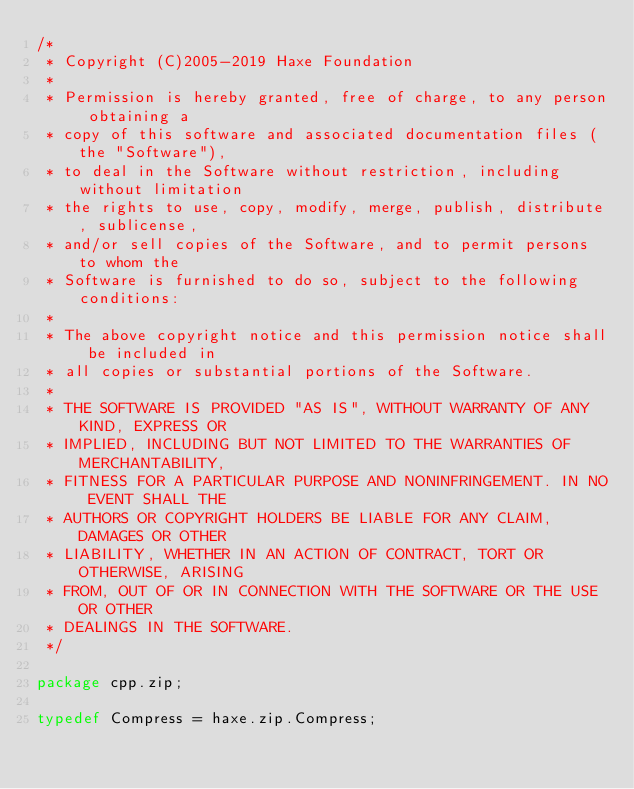<code> <loc_0><loc_0><loc_500><loc_500><_Haxe_>/*
 * Copyright (C)2005-2019 Haxe Foundation
 *
 * Permission is hereby granted, free of charge, to any person obtaining a
 * copy of this software and associated documentation files (the "Software"),
 * to deal in the Software without restriction, including without limitation
 * the rights to use, copy, modify, merge, publish, distribute, sublicense,
 * and/or sell copies of the Software, and to permit persons to whom the
 * Software is furnished to do so, subject to the following conditions:
 *
 * The above copyright notice and this permission notice shall be included in
 * all copies or substantial portions of the Software.
 *
 * THE SOFTWARE IS PROVIDED "AS IS", WITHOUT WARRANTY OF ANY KIND, EXPRESS OR
 * IMPLIED, INCLUDING BUT NOT LIMITED TO THE WARRANTIES OF MERCHANTABILITY,
 * FITNESS FOR A PARTICULAR PURPOSE AND NONINFRINGEMENT. IN NO EVENT SHALL THE
 * AUTHORS OR COPYRIGHT HOLDERS BE LIABLE FOR ANY CLAIM, DAMAGES OR OTHER
 * LIABILITY, WHETHER IN AN ACTION OF CONTRACT, TORT OR OTHERWISE, ARISING
 * FROM, OUT OF OR IN CONNECTION WITH THE SOFTWARE OR THE USE OR OTHER
 * DEALINGS IN THE SOFTWARE.
 */

package cpp.zip;

typedef Compress = haxe.zip.Compress;
</code> 